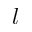Convert formula to latex. <formula><loc_0><loc_0><loc_500><loc_500>l</formula> 